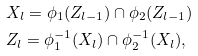Convert formula to latex. <formula><loc_0><loc_0><loc_500><loc_500>& X _ { l } = \phi _ { 1 } ( Z _ { l - 1 } ) \cap \phi _ { 2 } ( Z _ { l - 1 } ) \\ & Z _ { l } = \phi ^ { - 1 } _ { 1 } ( X _ { l } ) \cap \phi _ { 2 } ^ { - 1 } ( X _ { l } ) ,</formula> 